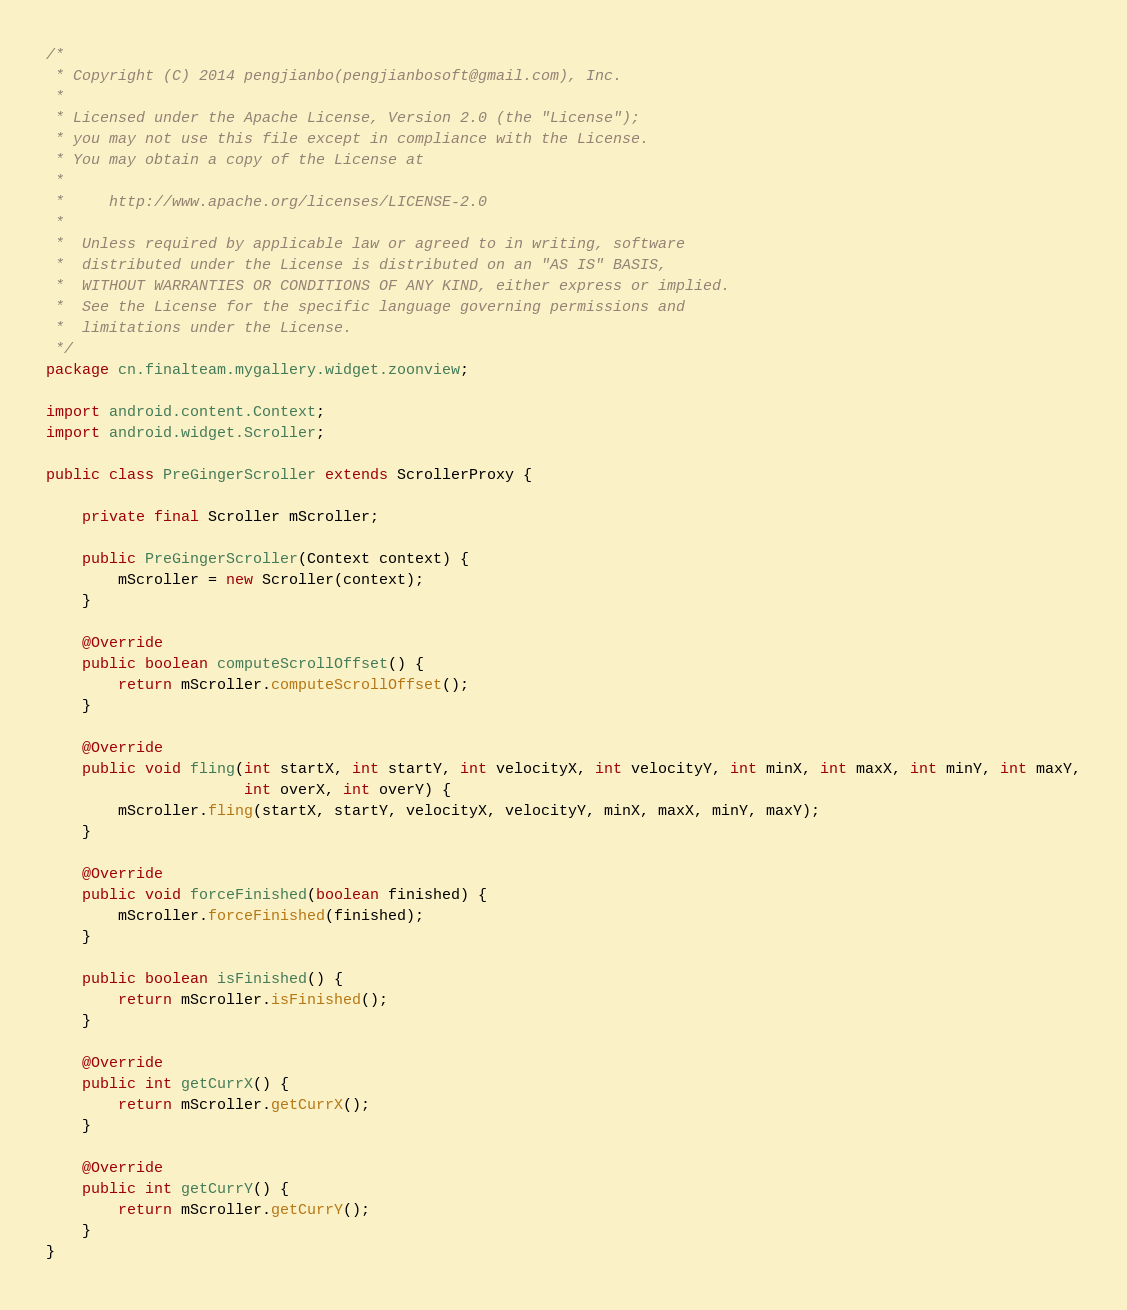<code> <loc_0><loc_0><loc_500><loc_500><_Java_>/*
 * Copyright (C) 2014 pengjianbo(pengjianbosoft@gmail.com), Inc.
 *
 * Licensed under the Apache License, Version 2.0 (the "License");
 * you may not use this file except in compliance with the License.
 * You may obtain a copy of the License at
 *
 *     http://www.apache.org/licenses/LICENSE-2.0
 *
 *  Unless required by applicable law or agreed to in writing, software
 *  distributed under the License is distributed on an "AS IS" BASIS,
 *  WITHOUT WARRANTIES OR CONDITIONS OF ANY KIND, either express or implied.
 *  See the License for the specific language governing permissions and
 *  limitations under the License.
 */
package cn.finalteam.mygallery.widget.zoonview;

import android.content.Context;
import android.widget.Scroller;

public class PreGingerScroller extends ScrollerProxy {

    private final Scroller mScroller;

    public PreGingerScroller(Context context) {
        mScroller = new Scroller(context);
    }

    @Override
    public boolean computeScrollOffset() {
        return mScroller.computeScrollOffset();
    }

    @Override
    public void fling(int startX, int startY, int velocityX, int velocityY, int minX, int maxX, int minY, int maxY,
                      int overX, int overY) {
        mScroller.fling(startX, startY, velocityX, velocityY, minX, maxX, minY, maxY);
    }

    @Override
    public void forceFinished(boolean finished) {
        mScroller.forceFinished(finished);
    }

    public boolean isFinished() {
        return mScroller.isFinished();
    }

    @Override
    public int getCurrX() {
        return mScroller.getCurrX();
    }

    @Override
    public int getCurrY() {
        return mScroller.getCurrY();
    }
}</code> 